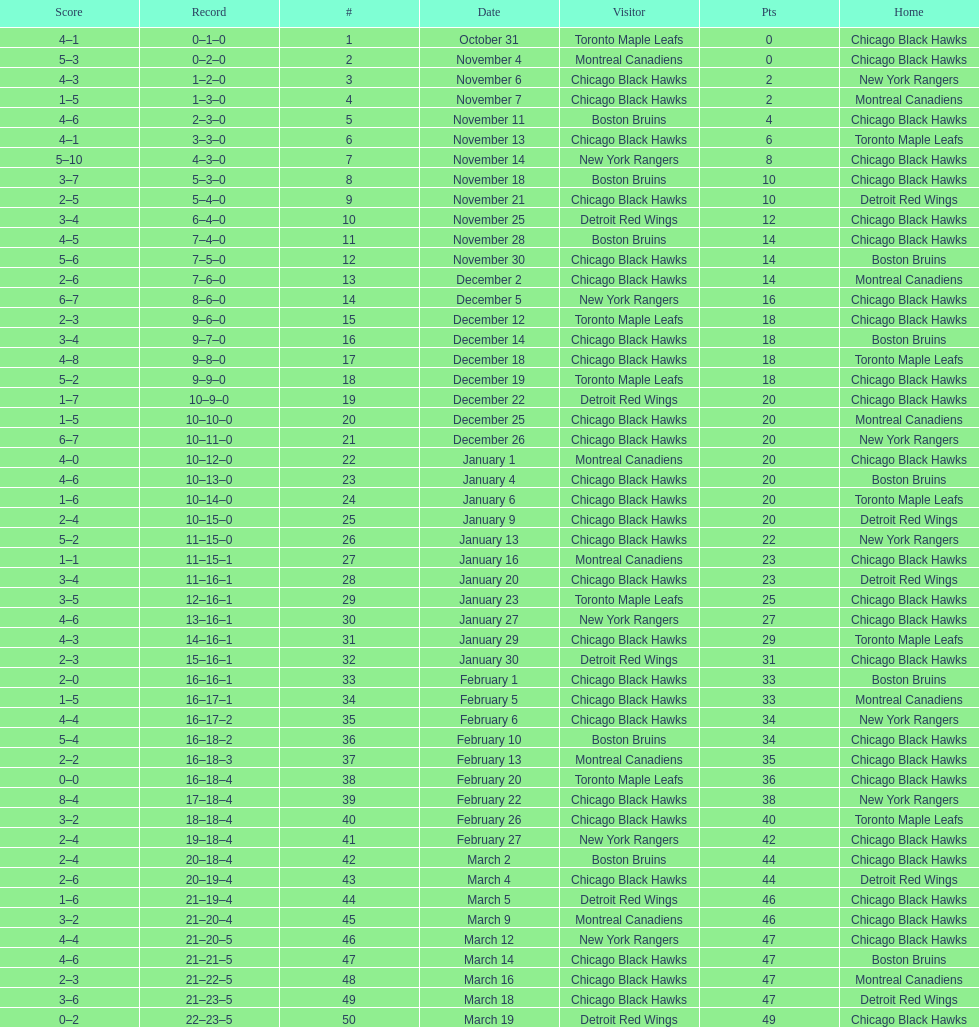Parse the table in full. {'header': ['Score', 'Record', '#', 'Date', 'Visitor', 'Pts', 'Home'], 'rows': [['4–1', '0–1–0', '1', 'October 31', 'Toronto Maple Leafs', '0', 'Chicago Black Hawks'], ['5–3', '0–2–0', '2', 'November 4', 'Montreal Canadiens', '0', 'Chicago Black Hawks'], ['4–3', '1–2–0', '3', 'November 6', 'Chicago Black Hawks', '2', 'New York Rangers'], ['1–5', '1–3–0', '4', 'November 7', 'Chicago Black Hawks', '2', 'Montreal Canadiens'], ['4–6', '2–3–0', '5', 'November 11', 'Boston Bruins', '4', 'Chicago Black Hawks'], ['4–1', '3–3–0', '6', 'November 13', 'Chicago Black Hawks', '6', 'Toronto Maple Leafs'], ['5–10', '4–3–0', '7', 'November 14', 'New York Rangers', '8', 'Chicago Black Hawks'], ['3–7', '5–3–0', '8', 'November 18', 'Boston Bruins', '10', 'Chicago Black Hawks'], ['2–5', '5–4–0', '9', 'November 21', 'Chicago Black Hawks', '10', 'Detroit Red Wings'], ['3–4', '6–4–0', '10', 'November 25', 'Detroit Red Wings', '12', 'Chicago Black Hawks'], ['4–5', '7–4–0', '11', 'November 28', 'Boston Bruins', '14', 'Chicago Black Hawks'], ['5–6', '7–5–0', '12', 'November 30', 'Chicago Black Hawks', '14', 'Boston Bruins'], ['2–6', '7–6–0', '13', 'December 2', 'Chicago Black Hawks', '14', 'Montreal Canadiens'], ['6–7', '8–6–0', '14', 'December 5', 'New York Rangers', '16', 'Chicago Black Hawks'], ['2–3', '9–6–0', '15', 'December 12', 'Toronto Maple Leafs', '18', 'Chicago Black Hawks'], ['3–4', '9–7–0', '16', 'December 14', 'Chicago Black Hawks', '18', 'Boston Bruins'], ['4–8', '9–8–0', '17', 'December 18', 'Chicago Black Hawks', '18', 'Toronto Maple Leafs'], ['5–2', '9–9–0', '18', 'December 19', 'Toronto Maple Leafs', '18', 'Chicago Black Hawks'], ['1–7', '10–9–0', '19', 'December 22', 'Detroit Red Wings', '20', 'Chicago Black Hawks'], ['1–5', '10–10–0', '20', 'December 25', 'Chicago Black Hawks', '20', 'Montreal Canadiens'], ['6–7', '10–11–0', '21', 'December 26', 'Chicago Black Hawks', '20', 'New York Rangers'], ['4–0', '10–12–0', '22', 'January 1', 'Montreal Canadiens', '20', 'Chicago Black Hawks'], ['4–6', '10–13–0', '23', 'January 4', 'Chicago Black Hawks', '20', 'Boston Bruins'], ['1–6', '10–14–0', '24', 'January 6', 'Chicago Black Hawks', '20', 'Toronto Maple Leafs'], ['2–4', '10–15–0', '25', 'January 9', 'Chicago Black Hawks', '20', 'Detroit Red Wings'], ['5–2', '11–15–0', '26', 'January 13', 'Chicago Black Hawks', '22', 'New York Rangers'], ['1–1', '11–15–1', '27', 'January 16', 'Montreal Canadiens', '23', 'Chicago Black Hawks'], ['3–4', '11–16–1', '28', 'January 20', 'Chicago Black Hawks', '23', 'Detroit Red Wings'], ['3–5', '12–16–1', '29', 'January 23', 'Toronto Maple Leafs', '25', 'Chicago Black Hawks'], ['4–6', '13–16–1', '30', 'January 27', 'New York Rangers', '27', 'Chicago Black Hawks'], ['4–3', '14–16–1', '31', 'January 29', 'Chicago Black Hawks', '29', 'Toronto Maple Leafs'], ['2–3', '15–16–1', '32', 'January 30', 'Detroit Red Wings', '31', 'Chicago Black Hawks'], ['2–0', '16–16–1', '33', 'February 1', 'Chicago Black Hawks', '33', 'Boston Bruins'], ['1–5', '16–17–1', '34', 'February 5', 'Chicago Black Hawks', '33', 'Montreal Canadiens'], ['4–4', '16–17–2', '35', 'February 6', 'Chicago Black Hawks', '34', 'New York Rangers'], ['5–4', '16–18–2', '36', 'February 10', 'Boston Bruins', '34', 'Chicago Black Hawks'], ['2–2', '16–18–3', '37', 'February 13', 'Montreal Canadiens', '35', 'Chicago Black Hawks'], ['0–0', '16–18–4', '38', 'February 20', 'Toronto Maple Leafs', '36', 'Chicago Black Hawks'], ['8–4', '17–18–4', '39', 'February 22', 'Chicago Black Hawks', '38', 'New York Rangers'], ['3–2', '18–18–4', '40', 'February 26', 'Chicago Black Hawks', '40', 'Toronto Maple Leafs'], ['2–4', '19–18–4', '41', 'February 27', 'New York Rangers', '42', 'Chicago Black Hawks'], ['2–4', '20–18–4', '42', 'March 2', 'Boston Bruins', '44', 'Chicago Black Hawks'], ['2–6', '20–19–4', '43', 'March 4', 'Chicago Black Hawks', '44', 'Detroit Red Wings'], ['1–6', '21–19–4', '44', 'March 5', 'Detroit Red Wings', '46', 'Chicago Black Hawks'], ['3–2', '21–20–4', '45', 'March 9', 'Montreal Canadiens', '46', 'Chicago Black Hawks'], ['4–4', '21–20–5', '46', 'March 12', 'New York Rangers', '47', 'Chicago Black Hawks'], ['4–6', '21–21–5', '47', 'March 14', 'Chicago Black Hawks', '47', 'Boston Bruins'], ['2–3', '21–22–5', '48', 'March 16', 'Chicago Black Hawks', '47', 'Montreal Canadiens'], ['3–6', '21–23–5', '49', 'March 18', 'Chicago Black Hawks', '47', 'Detroit Red Wings'], ['0–2', '22–23–5', '50', 'March 19', 'Detroit Red Wings', '49', 'Chicago Black Hawks']]} Tell me the number of points the blackhawks had on march 4. 44. 